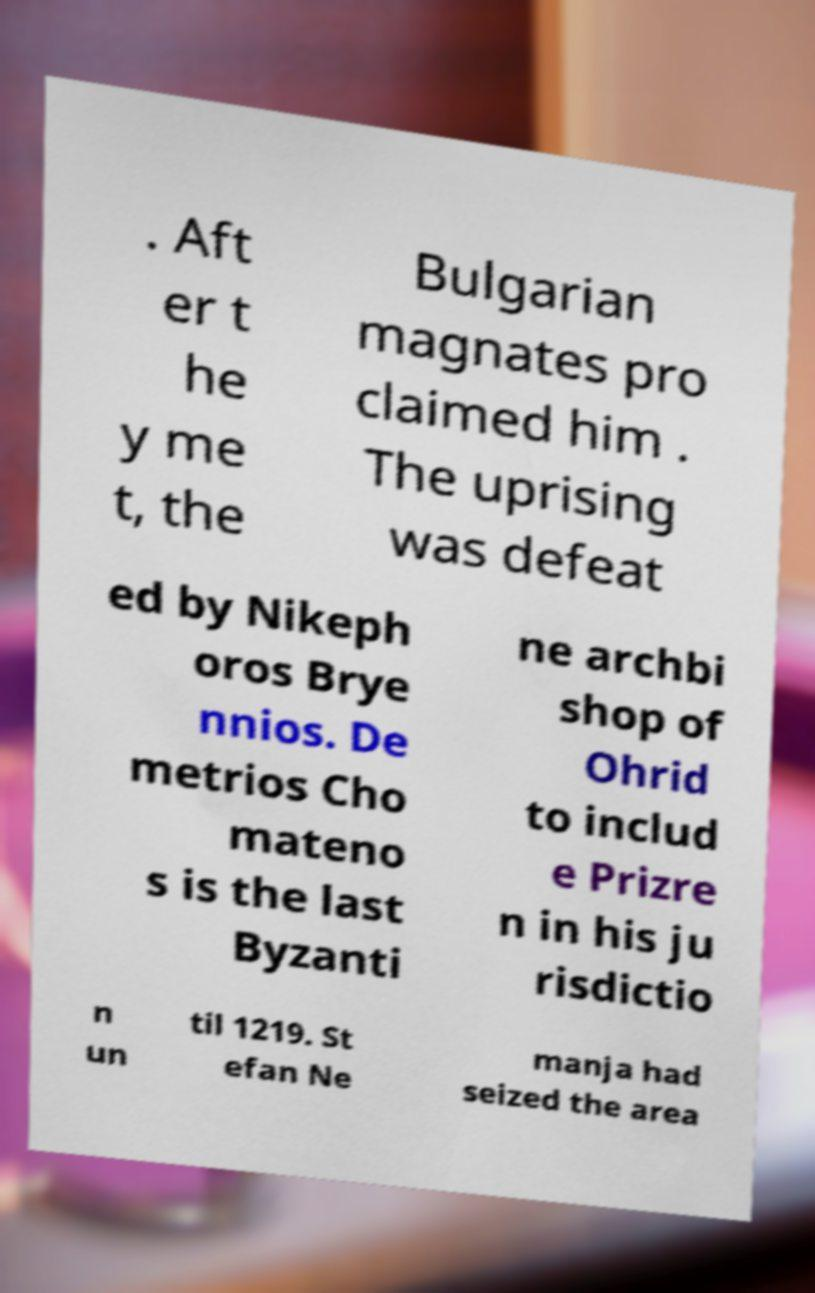For documentation purposes, I need the text within this image transcribed. Could you provide that? . Aft er t he y me t, the Bulgarian magnates pro claimed him . The uprising was defeat ed by Nikeph oros Brye nnios. De metrios Cho mateno s is the last Byzanti ne archbi shop of Ohrid to includ e Prizre n in his ju risdictio n un til 1219. St efan Ne manja had seized the area 